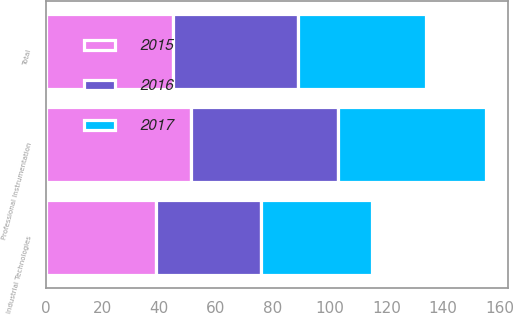Convert chart. <chart><loc_0><loc_0><loc_500><loc_500><stacked_bar_chart><ecel><fcel>Professional Instrumentation<fcel>Industrial Technologies<fcel>Total<nl><fcel>2017<fcel>52<fcel>39<fcel>45<nl><fcel>2016<fcel>52<fcel>37<fcel>44<nl><fcel>2015<fcel>51<fcel>39<fcel>45<nl></chart> 